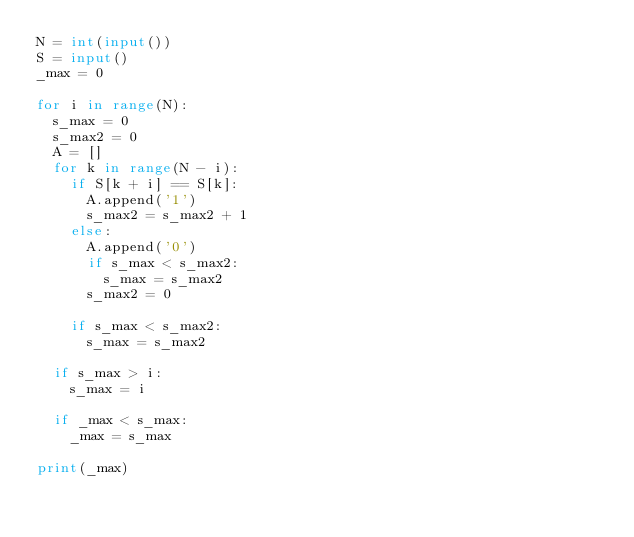<code> <loc_0><loc_0><loc_500><loc_500><_Python_>N = int(input())
S = input()
_max = 0

for i in range(N):
  s_max = 0
  s_max2 = 0
  A = []
  for k in range(N - i):
    if S[k + i] == S[k]:
      A.append('1')
      s_max2 = s_max2 + 1
    else:
      A.append('0')
      if s_max < s_max2:
        s_max = s_max2
      s_max2 = 0
      
    if s_max < s_max2:
      s_max = s_max2
      
  if s_max > i:
    s_max = i
    
  if _max < s_max:
    _max = s_max
    
print(_max)
  
  </code> 